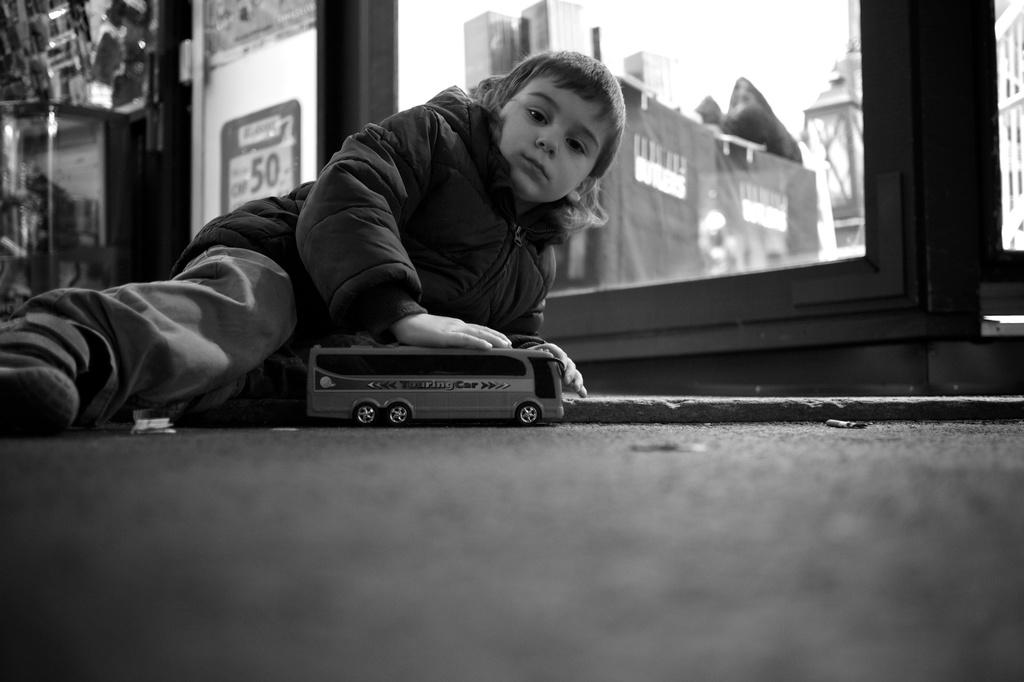What is the main subject of the image? The main subject of the image is a kid. What is the kid doing in the image? The kid is lying on a surface. What is the kid holding in the image? The kid is holding a toy. What architectural feature can be seen in the image? There is a glass window in the image. Can you describe the background of the image? The background of the image is not clear. What type of suit is the kid wearing in the image? There is no suit visible in the image; the kid is wearing a toy. Can you describe the cave in the background of the image? There is no cave present in the image; the background is not clear. 